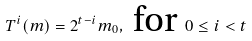Convert formula to latex. <formula><loc_0><loc_0><loc_500><loc_500>T ^ { i } ( m ) = 2 ^ { t - i } m _ { 0 } , \text { for } 0 \leq i < t</formula> 